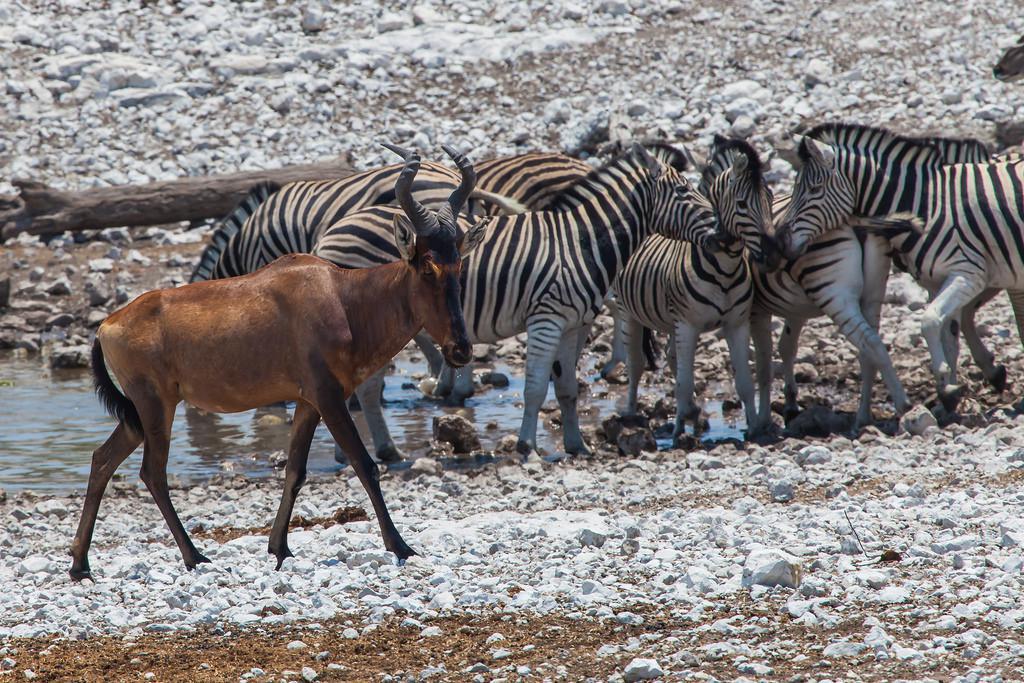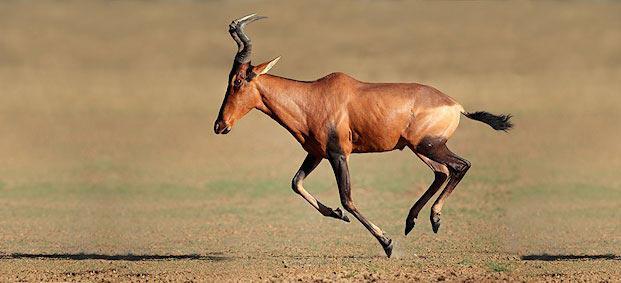The first image is the image on the left, the second image is the image on the right. Given the left and right images, does the statement "In at least one image there is a single elk walking right." hold true? Answer yes or no. Yes. The first image is the image on the left, the second image is the image on the right. Assess this claim about the two images: "One image includes a single adult horned animal, and the other image features a row of horned animals who face the same direction.". Correct or not? Answer yes or no. No. 